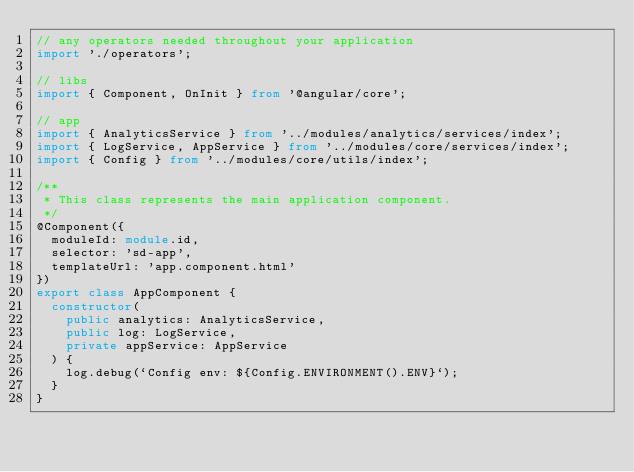Convert code to text. <code><loc_0><loc_0><loc_500><loc_500><_TypeScript_>// any operators needed throughout your application
import './operators';

// libs
import { Component, OnInit } from '@angular/core';

// app
import { AnalyticsService } from '../modules/analytics/services/index';
import { LogService, AppService } from '../modules/core/services/index';
import { Config } from '../modules/core/utils/index';

/**
 * This class represents the main application component.
 */
@Component({
  moduleId: module.id,
  selector: 'sd-app',
  templateUrl: 'app.component.html'
})
export class AppComponent {
  constructor(
    public analytics: AnalyticsService,
    public log: LogService,
    private appService: AppService
  ) {
    log.debug(`Config env: ${Config.ENVIRONMENT().ENV}`);
  }
}
</code> 